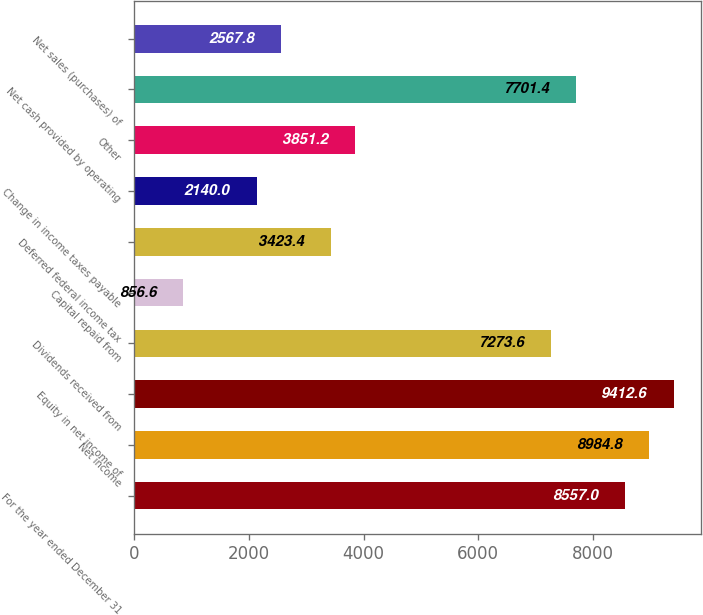Convert chart. <chart><loc_0><loc_0><loc_500><loc_500><bar_chart><fcel>For the year ended December 31<fcel>Net income<fcel>Equity in net income of<fcel>Dividends received from<fcel>Capital repaid from<fcel>Deferred federal income tax<fcel>Change in income taxes payable<fcel>Other<fcel>Net cash provided by operating<fcel>Net sales (purchases) of<nl><fcel>8557<fcel>8984.8<fcel>9412.6<fcel>7273.6<fcel>856.6<fcel>3423.4<fcel>2140<fcel>3851.2<fcel>7701.4<fcel>2567.8<nl></chart> 